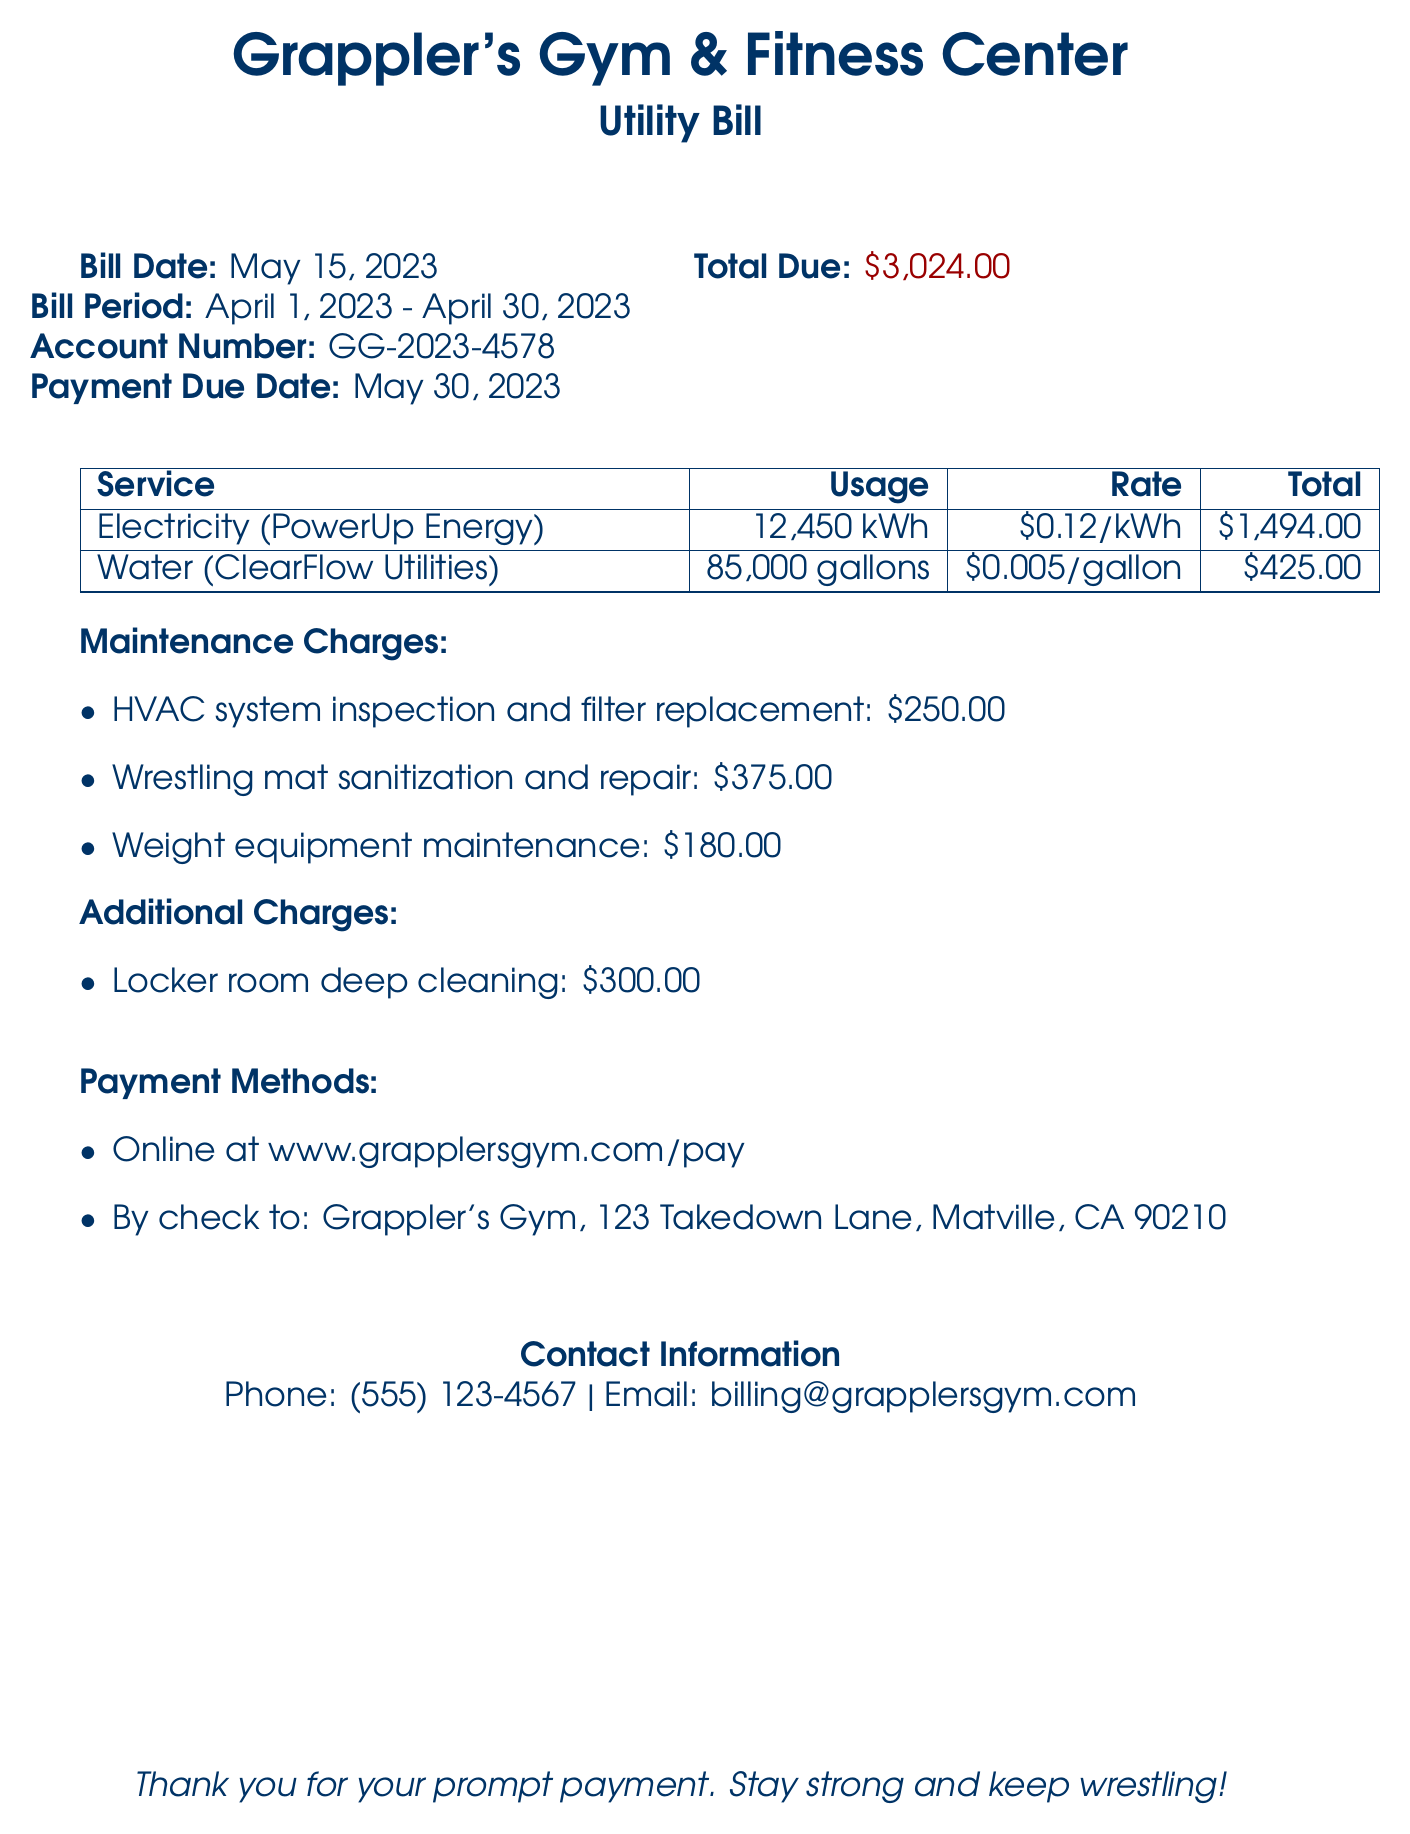What is the bill date? The bill date is explicitly stated in the document as May 15, 2023.
Answer: May 15, 2023 What is the total amount due? The total due amount is listed in the bill as $3,024.00.
Answer: $3,024.00 What is the usage of water? The document specifies the water usage as 85,000 gallons.
Answer: 85,000 gallons How much is the HVAC system inspection and filter replacement? The document lists the cost of HVAC system inspection and filter replacement as $250.00.
Answer: $250.00 What is the payment due date? The payment due date is mentioned in the document as May 30, 2023.
Answer: May 30, 2023 What is the total for electricity? The total for electricity service is stated as $1,494.00 in the document.
Answer: $1,494.00 What maintenance charge relates to wrestling mats? The charge related to wrestling mats is specified as sanitization and repair for $375.00.
Answer: Wrestling mat sanitization and repair: $375.00 How can payments be made? Payment methods are outlined in the document, including online and by check.
Answer: Online and by check What period does this bill cover? The bill period is detailed in the document as from April 1, 2023, to April 30, 2023.
Answer: April 1, 2023 - April 30, 2023 